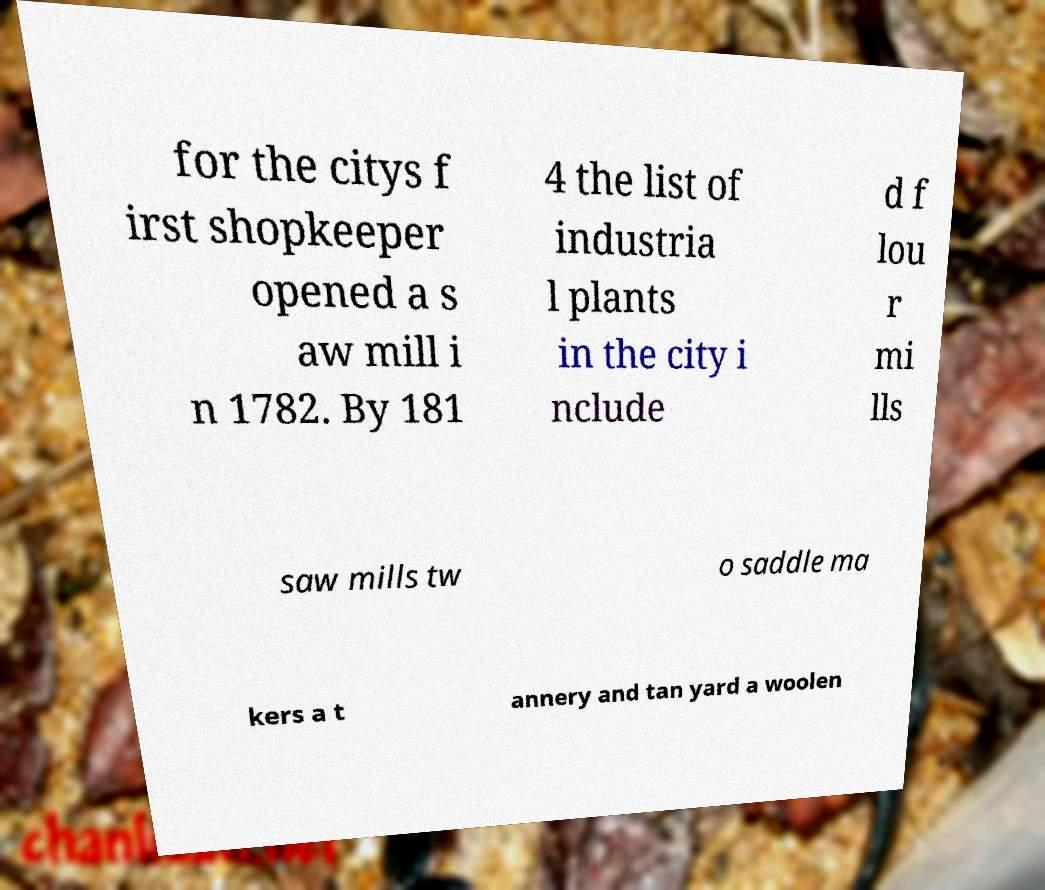Can you read and provide the text displayed in the image?This photo seems to have some interesting text. Can you extract and type it out for me? for the citys f irst shopkeeper opened a s aw mill i n 1782. By 181 4 the list of industria l plants in the city i nclude d f lou r mi lls saw mills tw o saddle ma kers a t annery and tan yard a woolen 